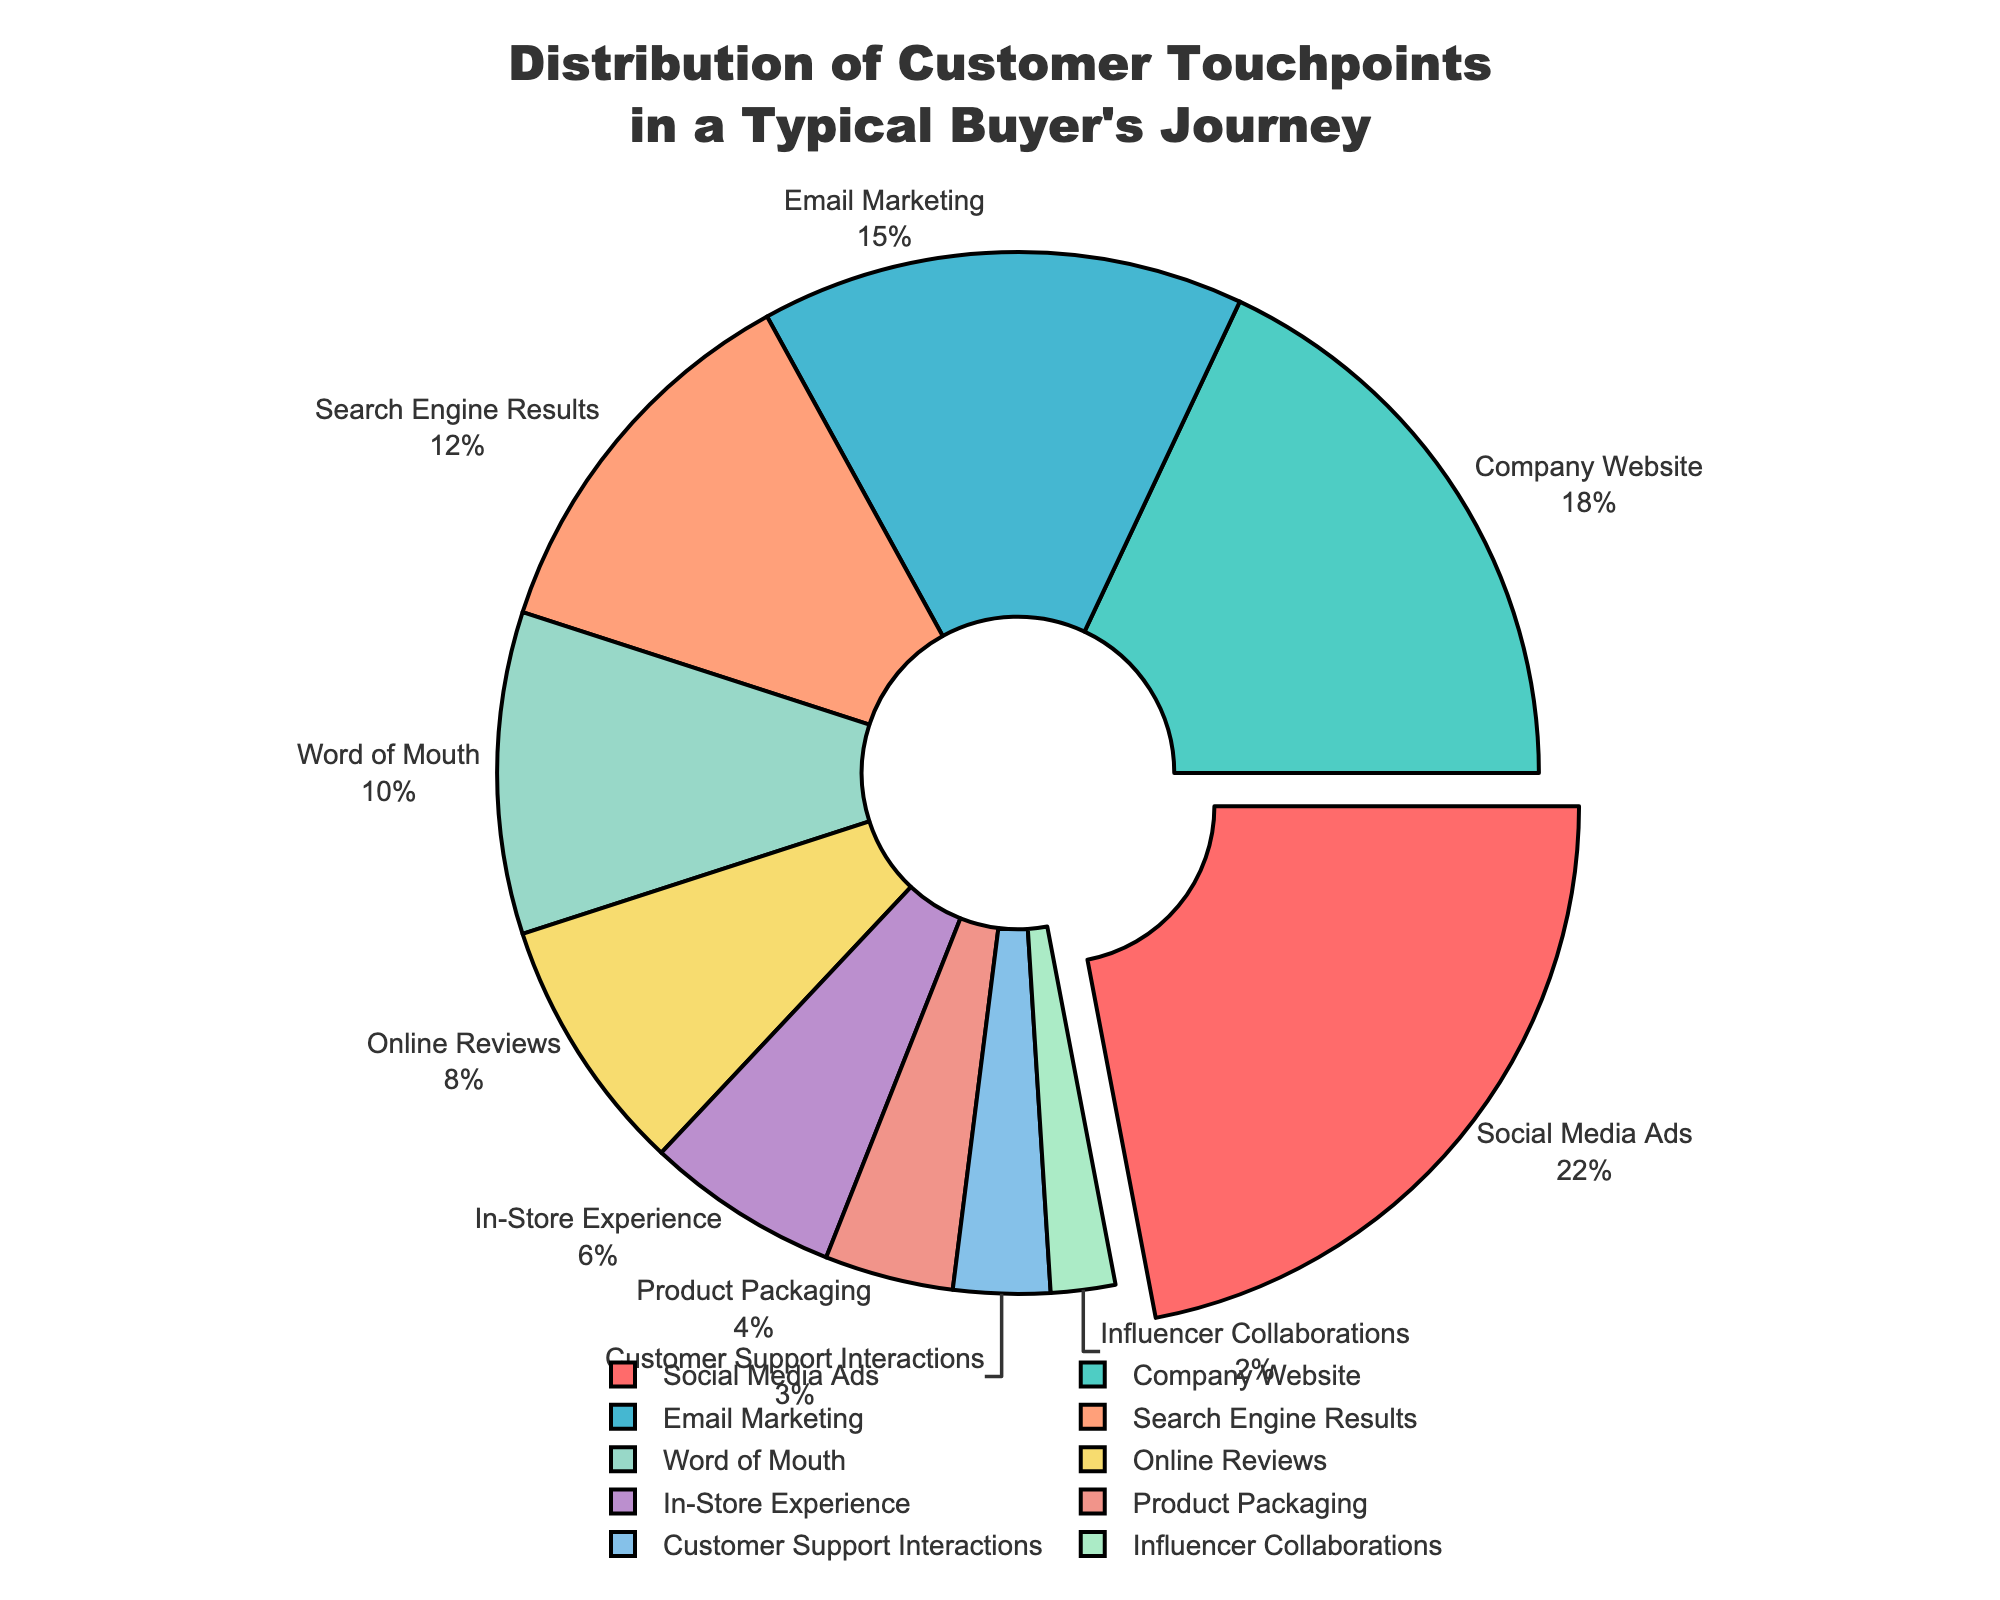Which touchpoint has the largest percentage? Look at the pie chart and identify the segment with the largest section and the percentage labeled on it.
Answer: Social Media Ads Which three touchpoints combined contribute to 45% of the total touchpoints? Find individual touchpoints and sum up their percentages until the total reaches 45% or close. Social Media Ads (22%), Company Website (18%), and Email Marketing (15%) combined contribute more than 45%. To get exactly 45%, take Social Media Ads (22%), Company Website (18%), and a portion of Email Marketing (5%).
Answer: Social Media Ads, Company Website, Email Marketing (part) Which touchpoint has the smallest percentage? Identify the segment with the smallest section in the pie chart and note its label and percentage.
Answer: Influencer Collaborations How does the percentage of Social Media Ads compare to that of Company Website? Look at the percentages of Social Media Ads and Company Website. Compare them directly by noting the values and the difference.
Answer: Social Media Ads is 4% higher than Company Website What is the combined percentage of Online Reviews and In-Store Experience? Simply add the percentages of Online Reviews (8%) and In-Store Experience (6%).
Answer: 14% Which touchpoint is displayed in green on the pie chart? Notice the color coding of the segments and find the label associated with the green-colored section.
Answer: Company Website How much larger is the percentage for Search Engine Results compared to Customer Support Interactions? Subtract the percentage of Customer Support Interactions from the percentage of Search Engine Results (12% - 3%).
Answer: 9% What is the total percentage of touchpoints that are less than 10% each? Identify touchpoints with less than 10% each: Word of Mouth (10%), Online Reviews (8%), In-Store Experience (6%), Product Packaging (4%), Customer Support Interactions (3%), Influencer Collaborations (2%). Add these percentages together.
Answer: 33% Which two touchpoints have a combined percentage equal to that of Social Media Ads? Look for pairs of touchpoints whose percentages sum up to 22% (same as Social Media Ads). Email Marketing (15%) and Search Engine Results (12%) exceed 22%, adjust by taking Email Marketing (15%) and a part of Search Engine Results (7%). Another pair is Email Marketing (15%) and Word of Mouth (10%).
Answer: Email Marketing and Word of Mouth (part) Which touchpoint segment is displayed in a light-colored blue? Identify the light blue segment in the pie chart and note the touchpoint it represents.
Answer: Search Engine Results 